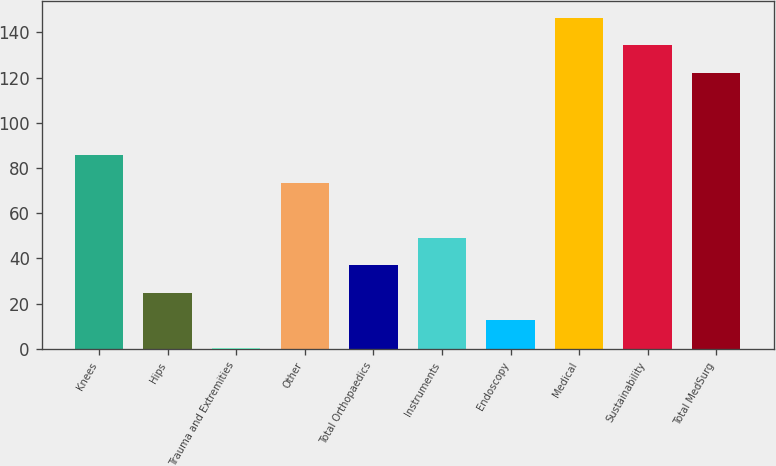<chart> <loc_0><loc_0><loc_500><loc_500><bar_chart><fcel>Knees<fcel>Hips<fcel>Trauma and Extremities<fcel>Other<fcel>Total Orthopaedics<fcel>Instruments<fcel>Endoscopy<fcel>Medical<fcel>Sustainability<fcel>Total MedSurg<nl><fcel>85.59<fcel>24.74<fcel>0.4<fcel>73.42<fcel>36.91<fcel>49.08<fcel>12.57<fcel>146.44<fcel>134.27<fcel>122.1<nl></chart> 